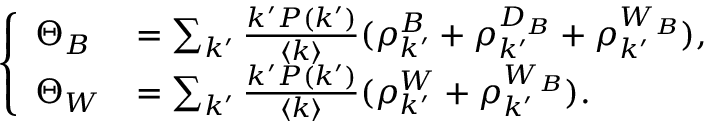<formula> <loc_0><loc_0><loc_500><loc_500>\left \{ \begin{array} { l l } { \Theta _ { B } } & { = \sum _ { k ^ { \prime } } \frac { k ^ { \prime } P ( k ^ { \prime } ) } { \langle k \rangle } ( \rho _ { k ^ { \prime } } ^ { B } + \rho _ { k ^ { \prime } } ^ { D _ { B } } + \rho _ { k ^ { \prime } } ^ { W _ { B } } ) , } \\ { \Theta _ { W } } & { = \sum _ { k ^ { \prime } } \frac { k ^ { \prime } P ( k ^ { \prime } ) } { \langle k \rangle } ( \rho _ { k ^ { \prime } } ^ { W } + \rho _ { k ^ { \prime } } ^ { W _ { B } } ) . } \end{array}</formula> 